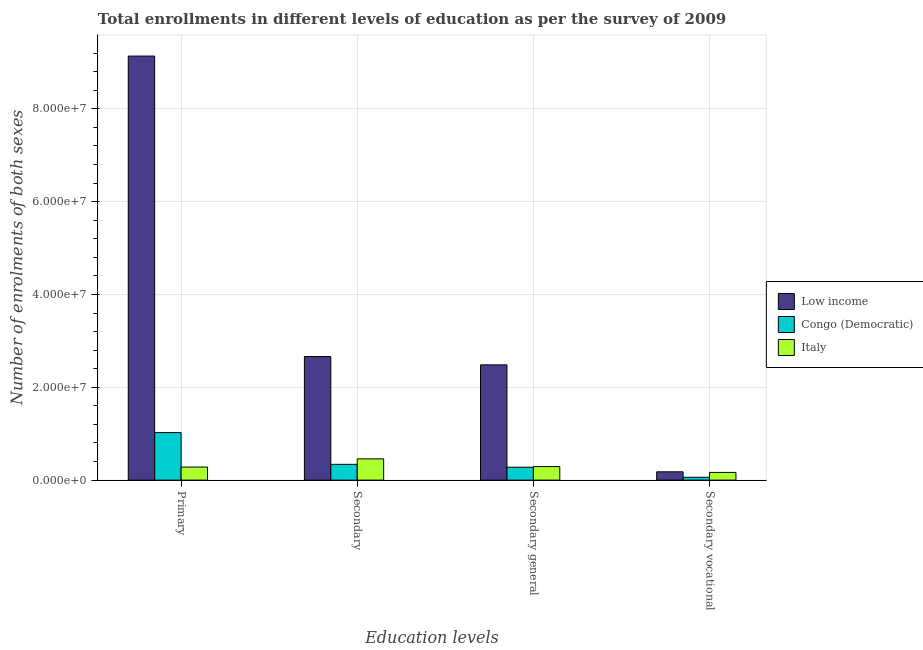How many different coloured bars are there?
Your answer should be compact. 3. How many groups of bars are there?
Make the answer very short. 4. How many bars are there on the 3rd tick from the left?
Provide a succinct answer. 3. What is the label of the 1st group of bars from the left?
Ensure brevity in your answer.  Primary. What is the number of enrolments in secondary general education in Congo (Democratic)?
Make the answer very short. 2.78e+06. Across all countries, what is the maximum number of enrolments in secondary vocational education?
Keep it short and to the point. 1.79e+06. Across all countries, what is the minimum number of enrolments in secondary education?
Give a very brief answer. 3.40e+06. In which country was the number of enrolments in secondary vocational education maximum?
Keep it short and to the point. Low income. What is the total number of enrolments in secondary general education in the graph?
Provide a short and direct response. 3.05e+07. What is the difference between the number of enrolments in primary education in Italy and that in Low income?
Offer a terse response. -8.85e+07. What is the difference between the number of enrolments in secondary education in Congo (Democratic) and the number of enrolments in secondary vocational education in Low income?
Provide a short and direct response. 1.61e+06. What is the average number of enrolments in secondary vocational education per country?
Make the answer very short. 1.36e+06. What is the difference between the number of enrolments in primary education and number of enrolments in secondary education in Congo (Democratic)?
Make the answer very short. 6.85e+06. In how many countries, is the number of enrolments in primary education greater than 72000000 ?
Offer a terse response. 1. What is the ratio of the number of enrolments in primary education in Low income to that in Italy?
Keep it short and to the point. 32.41. Is the number of enrolments in secondary general education in Low income less than that in Italy?
Your answer should be very brief. No. What is the difference between the highest and the second highest number of enrolments in secondary vocational education?
Your answer should be compact. 1.27e+05. What is the difference between the highest and the lowest number of enrolments in secondary education?
Provide a short and direct response. 2.32e+07. What does the 2nd bar from the left in Primary represents?
Offer a very short reply. Congo (Democratic). Is it the case that in every country, the sum of the number of enrolments in primary education and number of enrolments in secondary education is greater than the number of enrolments in secondary general education?
Your answer should be compact. Yes. How many bars are there?
Offer a terse response. 12. Are all the bars in the graph horizontal?
Keep it short and to the point. No. How many countries are there in the graph?
Ensure brevity in your answer.  3. Are the values on the major ticks of Y-axis written in scientific E-notation?
Offer a very short reply. Yes. Does the graph contain any zero values?
Offer a very short reply. No. Does the graph contain grids?
Ensure brevity in your answer.  Yes. How many legend labels are there?
Make the answer very short. 3. What is the title of the graph?
Give a very brief answer. Total enrollments in different levels of education as per the survey of 2009. Does "Panama" appear as one of the legend labels in the graph?
Ensure brevity in your answer.  No. What is the label or title of the X-axis?
Offer a very short reply. Education levels. What is the label or title of the Y-axis?
Provide a short and direct response. Number of enrolments of both sexes. What is the Number of enrolments of both sexes of Low income in Primary?
Your answer should be very brief. 9.14e+07. What is the Number of enrolments of both sexes in Congo (Democratic) in Primary?
Offer a very short reply. 1.02e+07. What is the Number of enrolments of both sexes in Italy in Primary?
Provide a short and direct response. 2.82e+06. What is the Number of enrolments of both sexes of Low income in Secondary?
Provide a short and direct response. 2.66e+07. What is the Number of enrolments of both sexes in Congo (Democratic) in Secondary?
Provide a short and direct response. 3.40e+06. What is the Number of enrolments of both sexes in Italy in Secondary?
Your response must be concise. 4.58e+06. What is the Number of enrolments of both sexes in Low income in Secondary general?
Your answer should be very brief. 2.48e+07. What is the Number of enrolments of both sexes in Congo (Democratic) in Secondary general?
Keep it short and to the point. 2.78e+06. What is the Number of enrolments of both sexes in Italy in Secondary general?
Your answer should be very brief. 2.91e+06. What is the Number of enrolments of both sexes in Low income in Secondary vocational?
Your response must be concise. 1.79e+06. What is the Number of enrolments of both sexes of Congo (Democratic) in Secondary vocational?
Give a very brief answer. 6.17e+05. What is the Number of enrolments of both sexes in Italy in Secondary vocational?
Your answer should be very brief. 1.66e+06. Across all Education levels, what is the maximum Number of enrolments of both sexes of Low income?
Keep it short and to the point. 9.14e+07. Across all Education levels, what is the maximum Number of enrolments of both sexes in Congo (Democratic)?
Your answer should be very brief. 1.02e+07. Across all Education levels, what is the maximum Number of enrolments of both sexes in Italy?
Give a very brief answer. 4.58e+06. Across all Education levels, what is the minimum Number of enrolments of both sexes of Low income?
Keep it short and to the point. 1.79e+06. Across all Education levels, what is the minimum Number of enrolments of both sexes of Congo (Democratic)?
Offer a very short reply. 6.17e+05. Across all Education levels, what is the minimum Number of enrolments of both sexes of Italy?
Give a very brief answer. 1.66e+06. What is the total Number of enrolments of both sexes in Low income in the graph?
Your answer should be very brief. 1.45e+08. What is the total Number of enrolments of both sexes of Congo (Democratic) in the graph?
Offer a very short reply. 1.70e+07. What is the total Number of enrolments of both sexes of Italy in the graph?
Ensure brevity in your answer.  1.20e+07. What is the difference between the Number of enrolments of both sexes of Low income in Primary and that in Secondary?
Keep it short and to the point. 6.47e+07. What is the difference between the Number of enrolments of both sexes of Congo (Democratic) in Primary and that in Secondary?
Your answer should be compact. 6.85e+06. What is the difference between the Number of enrolments of both sexes in Italy in Primary and that in Secondary?
Keep it short and to the point. -1.76e+06. What is the difference between the Number of enrolments of both sexes of Low income in Primary and that in Secondary general?
Give a very brief answer. 6.65e+07. What is the difference between the Number of enrolments of both sexes of Congo (Democratic) in Primary and that in Secondary general?
Ensure brevity in your answer.  7.46e+06. What is the difference between the Number of enrolments of both sexes of Italy in Primary and that in Secondary general?
Ensure brevity in your answer.  -9.42e+04. What is the difference between the Number of enrolments of both sexes of Low income in Primary and that in Secondary vocational?
Your answer should be compact. 8.96e+07. What is the difference between the Number of enrolments of both sexes in Congo (Democratic) in Primary and that in Secondary vocational?
Offer a very short reply. 9.63e+06. What is the difference between the Number of enrolments of both sexes of Italy in Primary and that in Secondary vocational?
Offer a terse response. 1.16e+06. What is the difference between the Number of enrolments of both sexes in Low income in Secondary and that in Secondary general?
Your answer should be very brief. 1.79e+06. What is the difference between the Number of enrolments of both sexes in Congo (Democratic) in Secondary and that in Secondary general?
Your answer should be compact. 6.17e+05. What is the difference between the Number of enrolments of both sexes of Italy in Secondary and that in Secondary general?
Ensure brevity in your answer.  1.66e+06. What is the difference between the Number of enrolments of both sexes in Low income in Secondary and that in Secondary vocational?
Make the answer very short. 2.48e+07. What is the difference between the Number of enrolments of both sexes in Congo (Democratic) in Secondary and that in Secondary vocational?
Offer a terse response. 2.78e+06. What is the difference between the Number of enrolments of both sexes of Italy in Secondary and that in Secondary vocational?
Make the answer very short. 2.91e+06. What is the difference between the Number of enrolments of both sexes in Low income in Secondary general and that in Secondary vocational?
Provide a short and direct response. 2.30e+07. What is the difference between the Number of enrolments of both sexes of Congo (Democratic) in Secondary general and that in Secondary vocational?
Make the answer very short. 2.16e+06. What is the difference between the Number of enrolments of both sexes of Italy in Secondary general and that in Secondary vocational?
Offer a terse response. 1.25e+06. What is the difference between the Number of enrolments of both sexes of Low income in Primary and the Number of enrolments of both sexes of Congo (Democratic) in Secondary?
Provide a short and direct response. 8.80e+07. What is the difference between the Number of enrolments of both sexes in Low income in Primary and the Number of enrolments of both sexes in Italy in Secondary?
Your answer should be very brief. 8.68e+07. What is the difference between the Number of enrolments of both sexes of Congo (Democratic) in Primary and the Number of enrolments of both sexes of Italy in Secondary?
Ensure brevity in your answer.  5.67e+06. What is the difference between the Number of enrolments of both sexes in Low income in Primary and the Number of enrolments of both sexes in Congo (Democratic) in Secondary general?
Your answer should be very brief. 8.86e+07. What is the difference between the Number of enrolments of both sexes of Low income in Primary and the Number of enrolments of both sexes of Italy in Secondary general?
Your answer should be very brief. 8.84e+07. What is the difference between the Number of enrolments of both sexes of Congo (Democratic) in Primary and the Number of enrolments of both sexes of Italy in Secondary general?
Your response must be concise. 7.33e+06. What is the difference between the Number of enrolments of both sexes in Low income in Primary and the Number of enrolments of both sexes in Congo (Democratic) in Secondary vocational?
Offer a terse response. 9.07e+07. What is the difference between the Number of enrolments of both sexes of Low income in Primary and the Number of enrolments of both sexes of Italy in Secondary vocational?
Offer a very short reply. 8.97e+07. What is the difference between the Number of enrolments of both sexes in Congo (Democratic) in Primary and the Number of enrolments of both sexes in Italy in Secondary vocational?
Keep it short and to the point. 8.58e+06. What is the difference between the Number of enrolments of both sexes of Low income in Secondary and the Number of enrolments of both sexes of Congo (Democratic) in Secondary general?
Provide a succinct answer. 2.38e+07. What is the difference between the Number of enrolments of both sexes in Low income in Secondary and the Number of enrolments of both sexes in Italy in Secondary general?
Make the answer very short. 2.37e+07. What is the difference between the Number of enrolments of both sexes in Congo (Democratic) in Secondary and the Number of enrolments of both sexes in Italy in Secondary general?
Your answer should be very brief. 4.85e+05. What is the difference between the Number of enrolments of both sexes of Low income in Secondary and the Number of enrolments of both sexes of Congo (Democratic) in Secondary vocational?
Ensure brevity in your answer.  2.60e+07. What is the difference between the Number of enrolments of both sexes of Low income in Secondary and the Number of enrolments of both sexes of Italy in Secondary vocational?
Provide a succinct answer. 2.50e+07. What is the difference between the Number of enrolments of both sexes in Congo (Democratic) in Secondary and the Number of enrolments of both sexes in Italy in Secondary vocational?
Your answer should be compact. 1.74e+06. What is the difference between the Number of enrolments of both sexes of Low income in Secondary general and the Number of enrolments of both sexes of Congo (Democratic) in Secondary vocational?
Give a very brief answer. 2.42e+07. What is the difference between the Number of enrolments of both sexes of Low income in Secondary general and the Number of enrolments of both sexes of Italy in Secondary vocational?
Ensure brevity in your answer.  2.32e+07. What is the difference between the Number of enrolments of both sexes of Congo (Democratic) in Secondary general and the Number of enrolments of both sexes of Italy in Secondary vocational?
Provide a succinct answer. 1.12e+06. What is the average Number of enrolments of both sexes in Low income per Education levels?
Ensure brevity in your answer.  3.62e+07. What is the average Number of enrolments of both sexes in Congo (Democratic) per Education levels?
Your answer should be compact. 4.26e+06. What is the average Number of enrolments of both sexes of Italy per Education levels?
Ensure brevity in your answer.  2.99e+06. What is the difference between the Number of enrolments of both sexes of Low income and Number of enrolments of both sexes of Congo (Democratic) in Primary?
Your answer should be compact. 8.11e+07. What is the difference between the Number of enrolments of both sexes of Low income and Number of enrolments of both sexes of Italy in Primary?
Offer a very short reply. 8.85e+07. What is the difference between the Number of enrolments of both sexes in Congo (Democratic) and Number of enrolments of both sexes in Italy in Primary?
Your answer should be very brief. 7.42e+06. What is the difference between the Number of enrolments of both sexes in Low income and Number of enrolments of both sexes in Congo (Democratic) in Secondary?
Give a very brief answer. 2.32e+07. What is the difference between the Number of enrolments of both sexes of Low income and Number of enrolments of both sexes of Italy in Secondary?
Ensure brevity in your answer.  2.20e+07. What is the difference between the Number of enrolments of both sexes in Congo (Democratic) and Number of enrolments of both sexes in Italy in Secondary?
Give a very brief answer. -1.18e+06. What is the difference between the Number of enrolments of both sexes of Low income and Number of enrolments of both sexes of Congo (Democratic) in Secondary general?
Provide a short and direct response. 2.21e+07. What is the difference between the Number of enrolments of both sexes in Low income and Number of enrolments of both sexes in Italy in Secondary general?
Offer a terse response. 2.19e+07. What is the difference between the Number of enrolments of both sexes of Congo (Democratic) and Number of enrolments of both sexes of Italy in Secondary general?
Provide a short and direct response. -1.32e+05. What is the difference between the Number of enrolments of both sexes in Low income and Number of enrolments of both sexes in Congo (Democratic) in Secondary vocational?
Keep it short and to the point. 1.17e+06. What is the difference between the Number of enrolments of both sexes in Low income and Number of enrolments of both sexes in Italy in Secondary vocational?
Your response must be concise. 1.27e+05. What is the difference between the Number of enrolments of both sexes of Congo (Democratic) and Number of enrolments of both sexes of Italy in Secondary vocational?
Ensure brevity in your answer.  -1.05e+06. What is the ratio of the Number of enrolments of both sexes of Low income in Primary to that in Secondary?
Offer a very short reply. 3.43. What is the ratio of the Number of enrolments of both sexes in Congo (Democratic) in Primary to that in Secondary?
Give a very brief answer. 3.01. What is the ratio of the Number of enrolments of both sexes in Italy in Primary to that in Secondary?
Provide a succinct answer. 0.62. What is the ratio of the Number of enrolments of both sexes in Low income in Primary to that in Secondary general?
Your answer should be very brief. 3.68. What is the ratio of the Number of enrolments of both sexes of Congo (Democratic) in Primary to that in Secondary general?
Ensure brevity in your answer.  3.68. What is the ratio of the Number of enrolments of both sexes of Italy in Primary to that in Secondary general?
Your answer should be very brief. 0.97. What is the ratio of the Number of enrolments of both sexes in Low income in Primary to that in Secondary vocational?
Offer a terse response. 51.04. What is the ratio of the Number of enrolments of both sexes in Congo (Democratic) in Primary to that in Secondary vocational?
Offer a terse response. 16.6. What is the ratio of the Number of enrolments of both sexes of Italy in Primary to that in Secondary vocational?
Make the answer very short. 1.7. What is the ratio of the Number of enrolments of both sexes of Low income in Secondary to that in Secondary general?
Offer a very short reply. 1.07. What is the ratio of the Number of enrolments of both sexes of Congo (Democratic) in Secondary to that in Secondary general?
Provide a succinct answer. 1.22. What is the ratio of the Number of enrolments of both sexes of Italy in Secondary to that in Secondary general?
Your response must be concise. 1.57. What is the ratio of the Number of enrolments of both sexes of Low income in Secondary to that in Secondary vocational?
Provide a short and direct response. 14.87. What is the ratio of the Number of enrolments of both sexes in Congo (Democratic) in Secondary to that in Secondary vocational?
Offer a very short reply. 5.51. What is the ratio of the Number of enrolments of both sexes in Italy in Secondary to that in Secondary vocational?
Your answer should be very brief. 2.75. What is the ratio of the Number of enrolments of both sexes in Low income in Secondary general to that in Secondary vocational?
Offer a terse response. 13.87. What is the ratio of the Number of enrolments of both sexes in Congo (Democratic) in Secondary general to that in Secondary vocational?
Ensure brevity in your answer.  4.51. What is the ratio of the Number of enrolments of both sexes in Italy in Secondary general to that in Secondary vocational?
Make the answer very short. 1.75. What is the difference between the highest and the second highest Number of enrolments of both sexes in Low income?
Offer a terse response. 6.47e+07. What is the difference between the highest and the second highest Number of enrolments of both sexes in Congo (Democratic)?
Offer a terse response. 6.85e+06. What is the difference between the highest and the second highest Number of enrolments of both sexes in Italy?
Provide a short and direct response. 1.66e+06. What is the difference between the highest and the lowest Number of enrolments of both sexes of Low income?
Your response must be concise. 8.96e+07. What is the difference between the highest and the lowest Number of enrolments of both sexes in Congo (Democratic)?
Keep it short and to the point. 9.63e+06. What is the difference between the highest and the lowest Number of enrolments of both sexes in Italy?
Provide a short and direct response. 2.91e+06. 